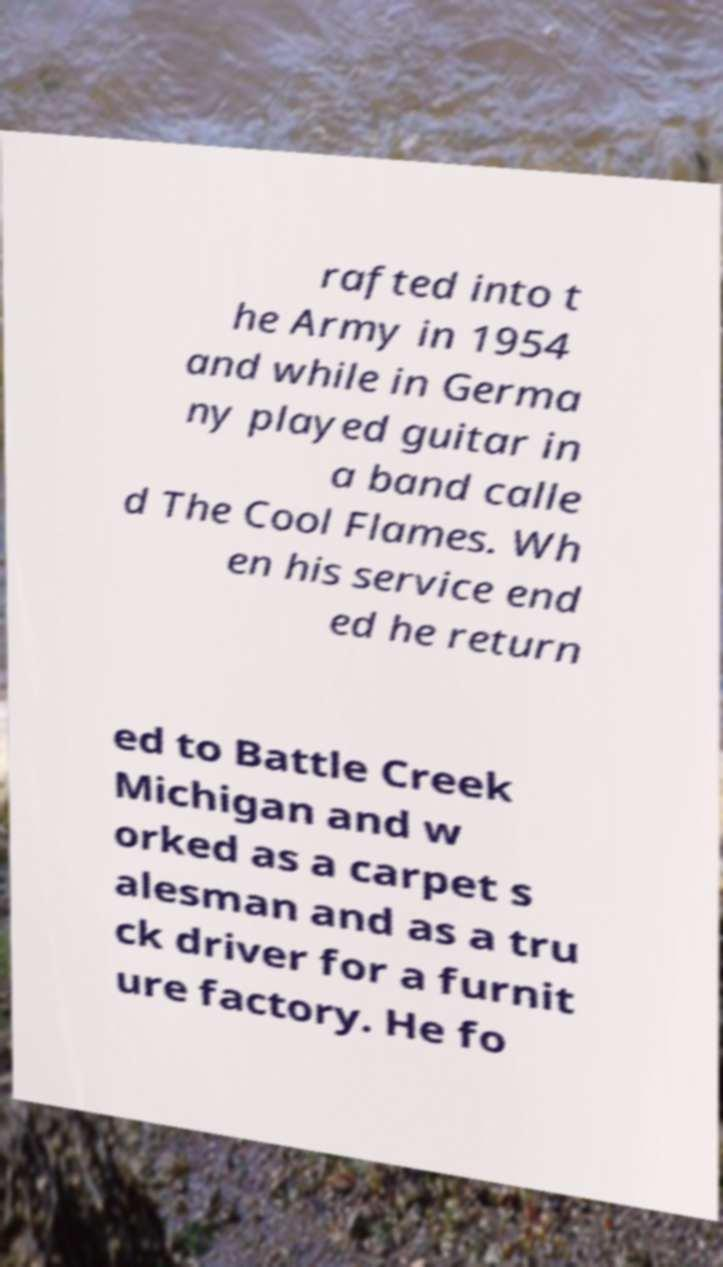Could you extract and type out the text from this image? rafted into t he Army in 1954 and while in Germa ny played guitar in a band calle d The Cool Flames. Wh en his service end ed he return ed to Battle Creek Michigan and w orked as a carpet s alesman and as a tru ck driver for a furnit ure factory. He fo 